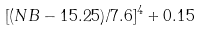Convert formula to latex. <formula><loc_0><loc_0><loc_500><loc_500>[ ( N B - 1 5 . 2 5 ) / 7 . 6 ] ^ { 4 } + 0 . 1 5</formula> 